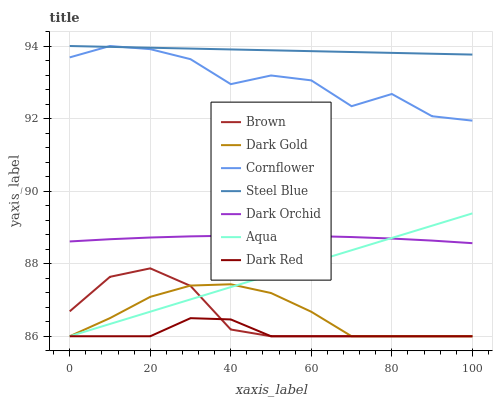Does Dark Red have the minimum area under the curve?
Answer yes or no. Yes. Does Steel Blue have the maximum area under the curve?
Answer yes or no. Yes. Does Cornflower have the minimum area under the curve?
Answer yes or no. No. Does Cornflower have the maximum area under the curve?
Answer yes or no. No. Is Steel Blue the smoothest?
Answer yes or no. Yes. Is Cornflower the roughest?
Answer yes or no. Yes. Is Dark Red the smoothest?
Answer yes or no. No. Is Dark Red the roughest?
Answer yes or no. No. Does Brown have the lowest value?
Answer yes or no. Yes. Does Cornflower have the lowest value?
Answer yes or no. No. Does Steel Blue have the highest value?
Answer yes or no. Yes. Does Dark Red have the highest value?
Answer yes or no. No. Is Dark Red less than Dark Orchid?
Answer yes or no. Yes. Is Cornflower greater than Dark Orchid?
Answer yes or no. Yes. Does Dark Red intersect Brown?
Answer yes or no. Yes. Is Dark Red less than Brown?
Answer yes or no. No. Is Dark Red greater than Brown?
Answer yes or no. No. Does Dark Red intersect Dark Orchid?
Answer yes or no. No. 